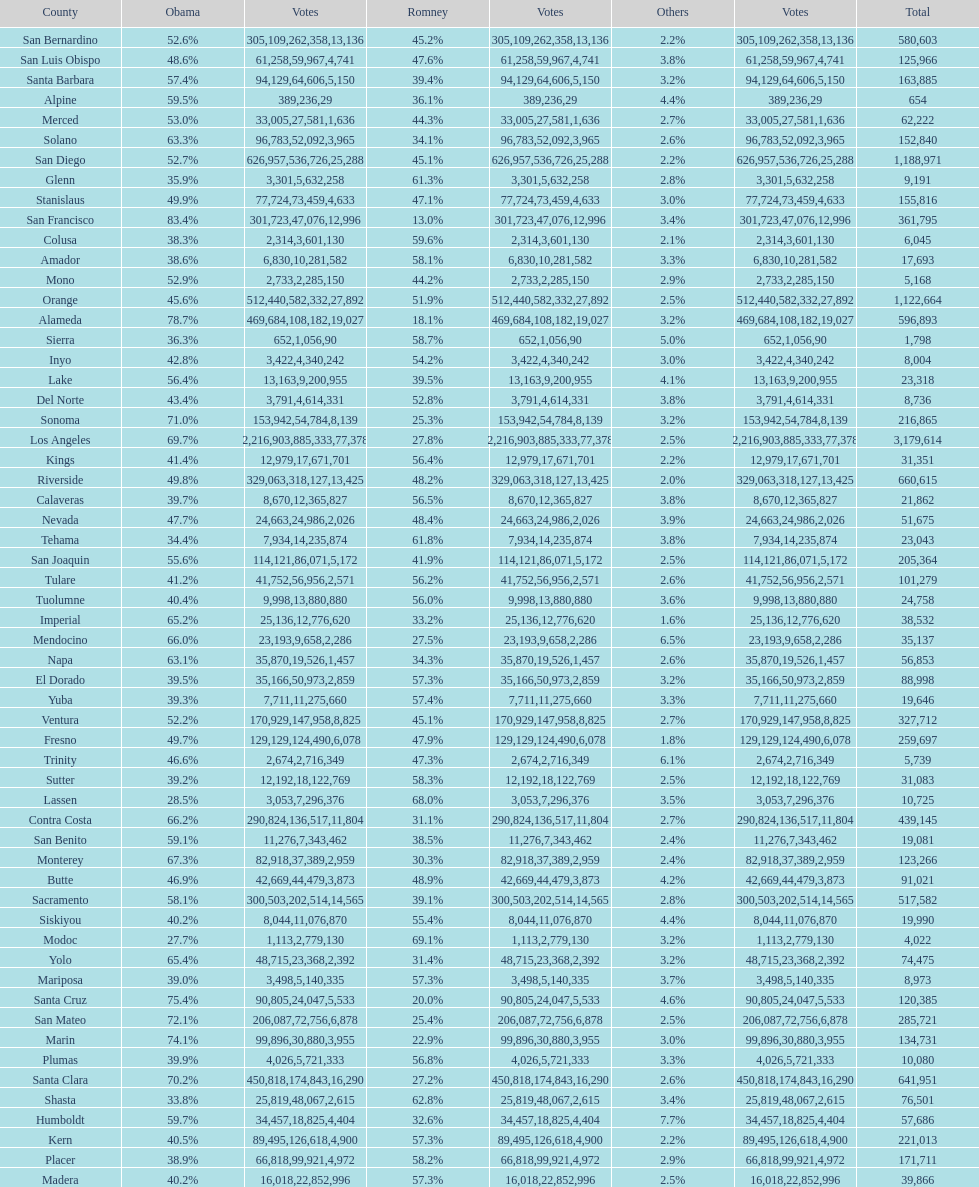What is the number of votes for obama for del norte and el dorado counties? 38957. Write the full table. {'header': ['County', 'Obama', 'Votes', 'Romney', 'Votes', 'Others', 'Votes', 'Total'], 'rows': [['San Bernardino', '52.6%', '305,109', '45.2%', '262,358', '2.2%', '13,136', '580,603'], ['San Luis Obispo', '48.6%', '61,258', '47.6%', '59,967', '3.8%', '4,741', '125,966'], ['Santa Barbara', '57.4%', '94,129', '39.4%', '64,606', '3.2%', '5,150', '163,885'], ['Alpine', '59.5%', '389', '36.1%', '236', '4.4%', '29', '654'], ['Merced', '53.0%', '33,005', '44.3%', '27,581', '2.7%', '1,636', '62,222'], ['Solano', '63.3%', '96,783', '34.1%', '52,092', '2.6%', '3,965', '152,840'], ['San Diego', '52.7%', '626,957', '45.1%', '536,726', '2.2%', '25,288', '1,188,971'], ['Glenn', '35.9%', '3,301', '61.3%', '5,632', '2.8%', '258', '9,191'], ['Stanislaus', '49.9%', '77,724', '47.1%', '73,459', '3.0%', '4,633', '155,816'], ['San Francisco', '83.4%', '301,723', '13.0%', '47,076', '3.4%', '12,996', '361,795'], ['Colusa', '38.3%', '2,314', '59.6%', '3,601', '2.1%', '130', '6,045'], ['Amador', '38.6%', '6,830', '58.1%', '10,281', '3.3%', '582', '17,693'], ['Mono', '52.9%', '2,733', '44.2%', '2,285', '2.9%', '150', '5,168'], ['Orange', '45.6%', '512,440', '51.9%', '582,332', '2.5%', '27,892', '1,122,664'], ['Alameda', '78.7%', '469,684', '18.1%', '108,182', '3.2%', '19,027', '596,893'], ['Sierra', '36.3%', '652', '58.7%', '1,056', '5.0%', '90', '1,798'], ['Inyo', '42.8%', '3,422', '54.2%', '4,340', '3.0%', '242', '8,004'], ['Lake', '56.4%', '13,163', '39.5%', '9,200', '4.1%', '955', '23,318'], ['Del Norte', '43.4%', '3,791', '52.8%', '4,614', '3.8%', '331', '8,736'], ['Sonoma', '71.0%', '153,942', '25.3%', '54,784', '3.2%', '8,139', '216,865'], ['Los Angeles', '69.7%', '2,216,903', '27.8%', '885,333', '2.5%', '77,378', '3,179,614'], ['Kings', '41.4%', '12,979', '56.4%', '17,671', '2.2%', '701', '31,351'], ['Riverside', '49.8%', '329,063', '48.2%', '318,127', '2.0%', '13,425', '660,615'], ['Calaveras', '39.7%', '8,670', '56.5%', '12,365', '3.8%', '827', '21,862'], ['Nevada', '47.7%', '24,663', '48.4%', '24,986', '3.9%', '2,026', '51,675'], ['Tehama', '34.4%', '7,934', '61.8%', '14,235', '3.8%', '874', '23,043'], ['San Joaquin', '55.6%', '114,121', '41.9%', '86,071', '2.5%', '5,172', '205,364'], ['Tulare', '41.2%', '41,752', '56.2%', '56,956', '2.6%', '2,571', '101,279'], ['Tuolumne', '40.4%', '9,998', '56.0%', '13,880', '3.6%', '880', '24,758'], ['Imperial', '65.2%', '25,136', '33.2%', '12,776', '1.6%', '620', '38,532'], ['Mendocino', '66.0%', '23,193', '27.5%', '9,658', '6.5%', '2,286', '35,137'], ['Napa', '63.1%', '35,870', '34.3%', '19,526', '2.6%', '1,457', '56,853'], ['El Dorado', '39.5%', '35,166', '57.3%', '50,973', '3.2%', '2,859', '88,998'], ['Yuba', '39.3%', '7,711', '57.4%', '11,275', '3.3%', '660', '19,646'], ['Ventura', '52.2%', '170,929', '45.1%', '147,958', '2.7%', '8,825', '327,712'], ['Fresno', '49.7%', '129,129', '47.9%', '124,490', '1.8%', '6,078', '259,697'], ['Trinity', '46.6%', '2,674', '47.3%', '2,716', '6.1%', '349', '5,739'], ['Sutter', '39.2%', '12,192', '58.3%', '18,122', '2.5%', '769', '31,083'], ['Lassen', '28.5%', '3,053', '68.0%', '7,296', '3.5%', '376', '10,725'], ['Contra Costa', '66.2%', '290,824', '31.1%', '136,517', '2.7%', '11,804', '439,145'], ['San Benito', '59.1%', '11,276', '38.5%', '7,343', '2.4%', '462', '19,081'], ['Monterey', '67.3%', '82,918', '30.3%', '37,389', '2.4%', '2,959', '123,266'], ['Butte', '46.9%', '42,669', '48.9%', '44,479', '4.2%', '3,873', '91,021'], ['Sacramento', '58.1%', '300,503', '39.1%', '202,514', '2.8%', '14,565', '517,582'], ['Siskiyou', '40.2%', '8,044', '55.4%', '11,076', '4.4%', '870', '19,990'], ['Modoc', '27.7%', '1,113', '69.1%', '2,779', '3.2%', '130', '4,022'], ['Yolo', '65.4%', '48,715', '31.4%', '23,368', '3.2%', '2,392', '74,475'], ['Mariposa', '39.0%', '3,498', '57.3%', '5,140', '3.7%', '335', '8,973'], ['Santa Cruz', '75.4%', '90,805', '20.0%', '24,047', '4.6%', '5,533', '120,385'], ['San Mateo', '72.1%', '206,087', '25.4%', '72,756', '2.5%', '6,878', '285,721'], ['Marin', '74.1%', '99,896', '22.9%', '30,880', '3.0%', '3,955', '134,731'], ['Plumas', '39.9%', '4,026', '56.8%', '5,721', '3.3%', '333', '10,080'], ['Santa Clara', '70.2%', '450,818', '27.2%', '174,843', '2.6%', '16,290', '641,951'], ['Shasta', '33.8%', '25,819', '62.8%', '48,067', '3.4%', '2,615', '76,501'], ['Humboldt', '59.7%', '34,457', '32.6%', '18,825', '7.7%', '4,404', '57,686'], ['Kern', '40.5%', '89,495', '57.3%', '126,618', '2.2%', '4,900', '221,013'], ['Placer', '38.9%', '66,818', '58.2%', '99,921', '2.9%', '4,972', '171,711'], ['Madera', '40.2%', '16,018', '57.3%', '22,852', '2.5%', '996', '39,866']]} 